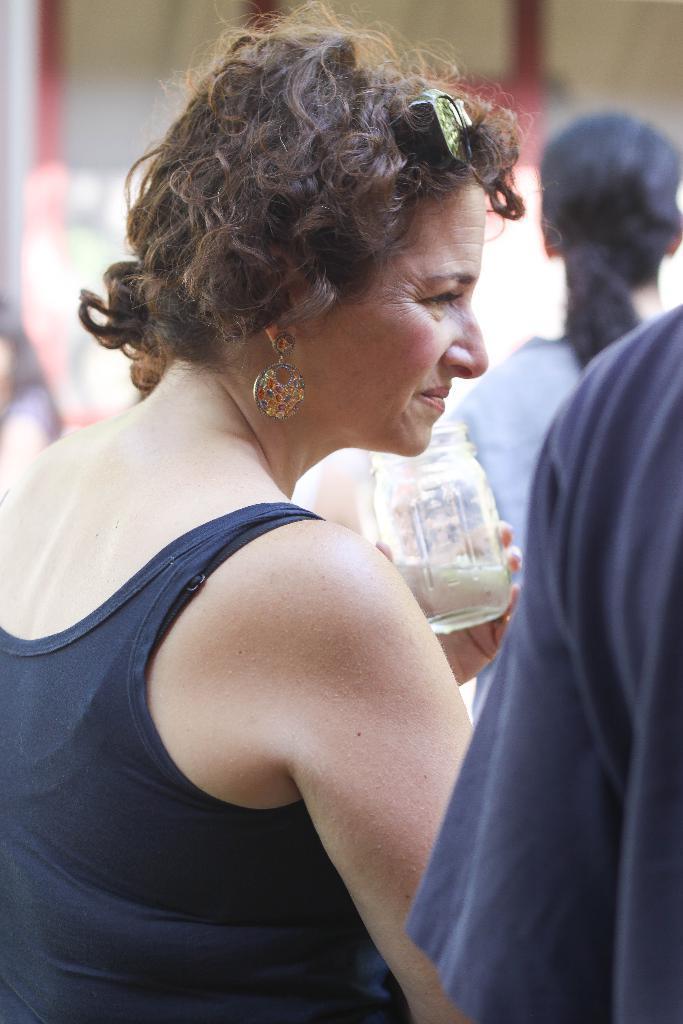How would you summarize this image in a sentence or two? In this picture we can see the group of people and a glass jar. In the background we can see some other items. 